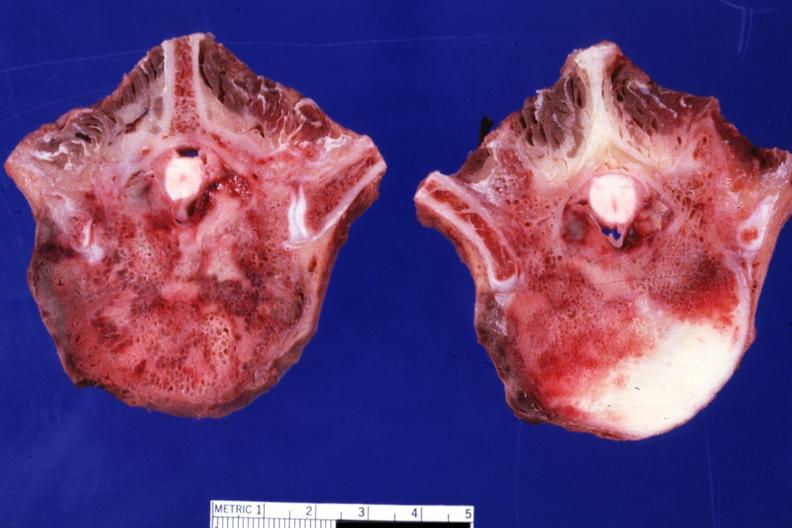s joints present?
Answer the question using a single word or phrase. Yes 